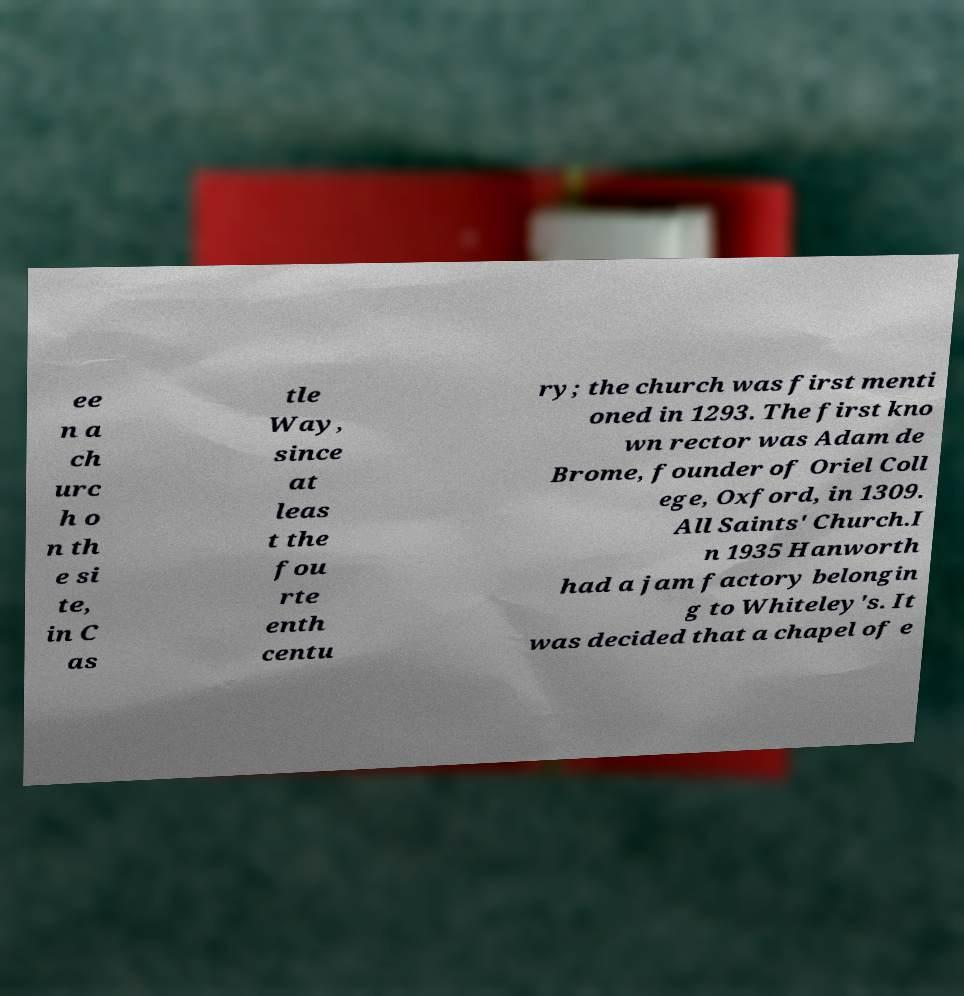There's text embedded in this image that I need extracted. Can you transcribe it verbatim? ee n a ch urc h o n th e si te, in C as tle Way, since at leas t the fou rte enth centu ry; the church was first menti oned in 1293. The first kno wn rector was Adam de Brome, founder of Oriel Coll ege, Oxford, in 1309. All Saints' Church.I n 1935 Hanworth had a jam factory belongin g to Whiteley's. It was decided that a chapel of e 